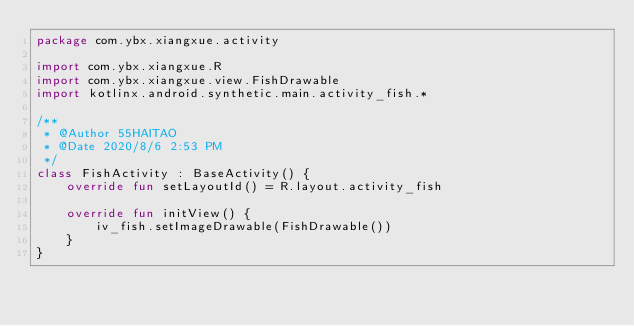Convert code to text. <code><loc_0><loc_0><loc_500><loc_500><_Kotlin_>package com.ybx.xiangxue.activity

import com.ybx.xiangxue.R
import com.ybx.xiangxue.view.FishDrawable
import kotlinx.android.synthetic.main.activity_fish.*

/**
 * @Author 55HAITAO
 * @Date 2020/8/6 2:53 PM
 */
class FishActivity : BaseActivity() {
    override fun setLayoutId() = R.layout.activity_fish

    override fun initView() {
        iv_fish.setImageDrawable(FishDrawable())
    }
}</code> 